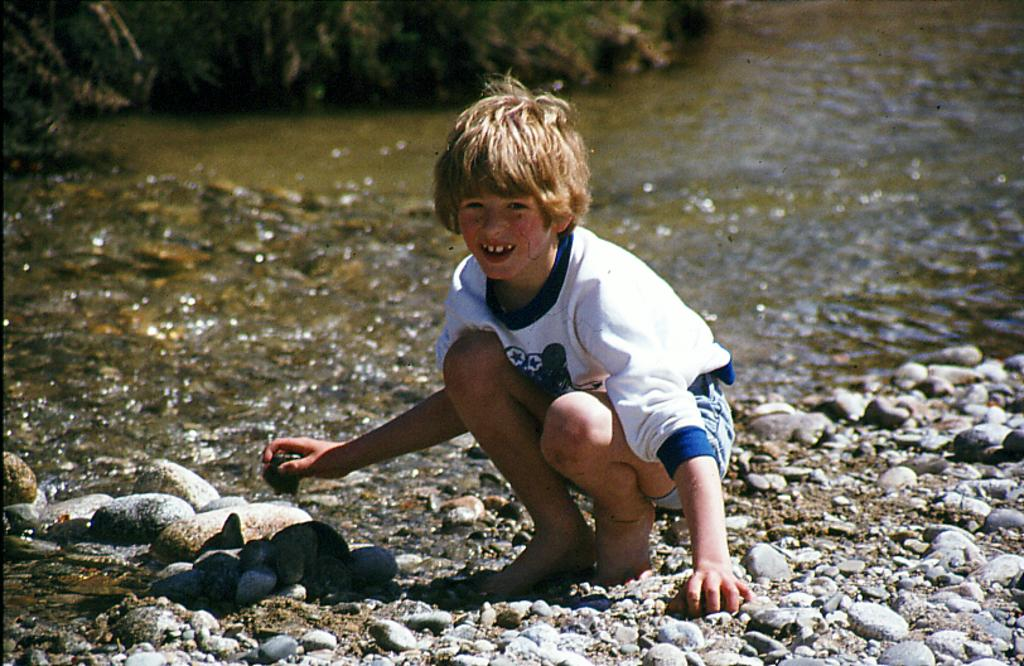Who is in the image? There is a boy in the image. What position is the boy in? The boy is in a squat position. What can be seen at the bottom of the image? There are rocks at the bottom of the image. What is visible in the image besides the boy and rocks? There is water visible in the image. What type of vegetation is in the background of the image? There are plants in the background of the image. What time does the clock in the image show? There is no clock present in the image. What is the purpose of the boy's squat position in the image? The purpose of the boy's squat position cannot be determined from the image alone, as it could be for various reasons such as exercise, play, or rest. 